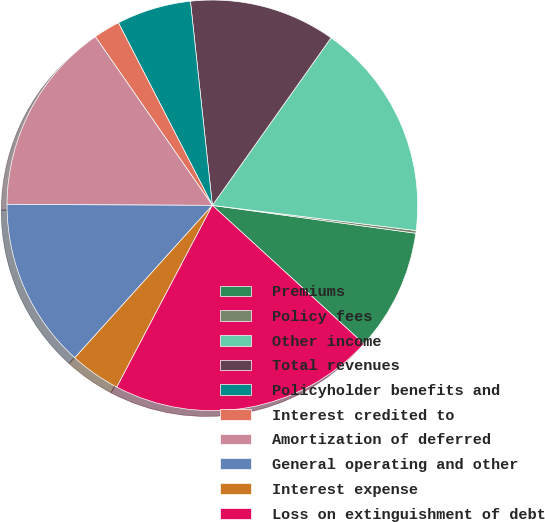Convert chart to OTSL. <chart><loc_0><loc_0><loc_500><loc_500><pie_chart><fcel>Premiums<fcel>Policy fees<fcel>Other income<fcel>Total revenues<fcel>Policyholder benefits and<fcel>Interest credited to<fcel>Amortization of deferred<fcel>General operating and other<fcel>Interest expense<fcel>Loss on extinguishment of debt<nl><fcel>9.62%<fcel>0.21%<fcel>17.15%<fcel>11.51%<fcel>5.86%<fcel>2.09%<fcel>15.27%<fcel>13.39%<fcel>3.98%<fcel>20.92%<nl></chart> 